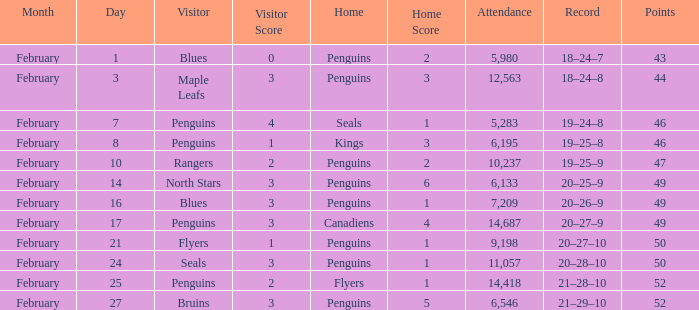Record of 21–29–10 had what total number of points? 1.0. 